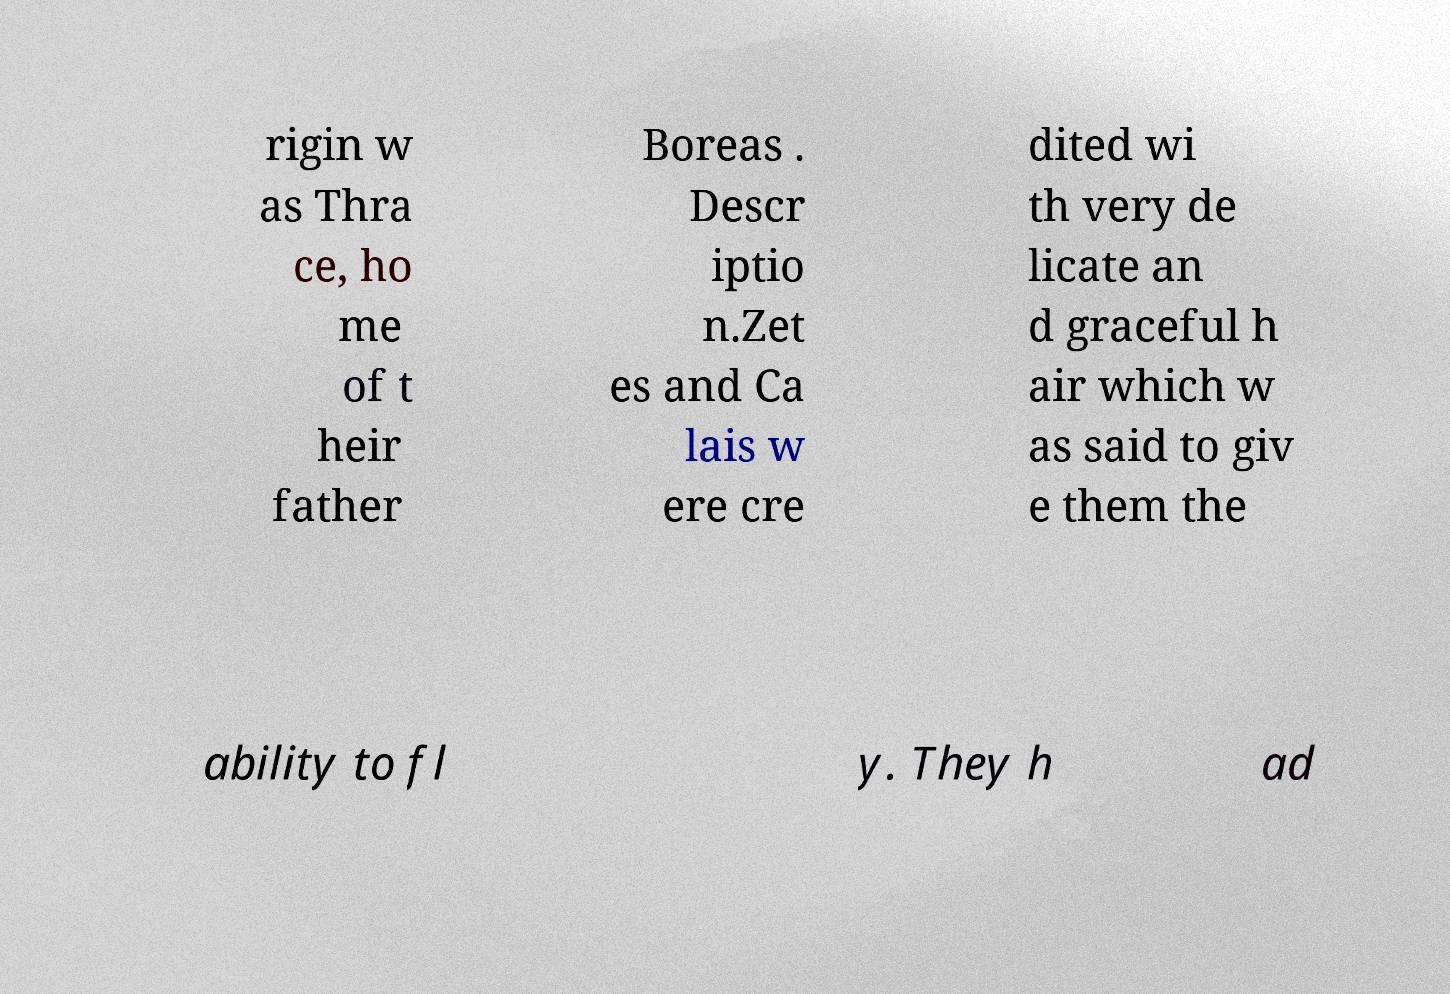I need the written content from this picture converted into text. Can you do that? rigin w as Thra ce, ho me of t heir father Boreas . Descr iptio n.Zet es and Ca lais w ere cre dited wi th very de licate an d graceful h air which w as said to giv e them the ability to fl y. They h ad 